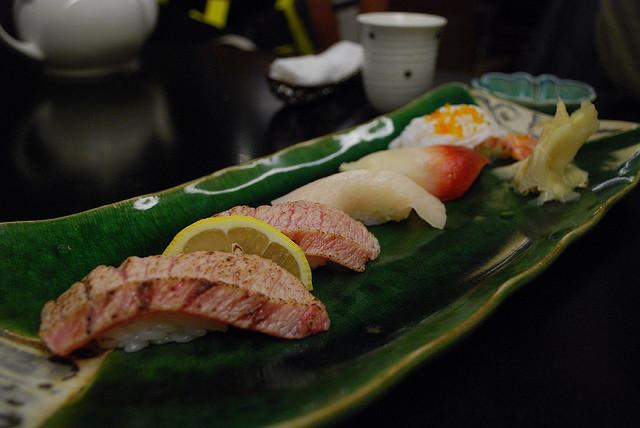Why would someone sit at this table?

Choices:
A) to eat
B) to craft
C) to work
D) to sew to eat 